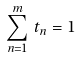<formula> <loc_0><loc_0><loc_500><loc_500>\sum _ { n = 1 } ^ { m } \, t _ { n } = 1</formula> 